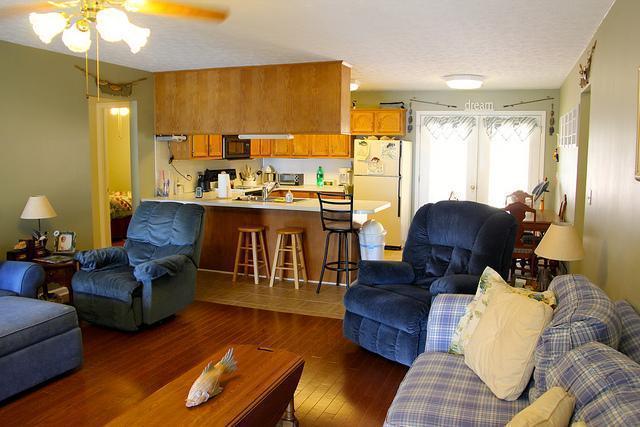What is on the brown table near the couch?
Indicate the correct response and explain using: 'Answer: answer
Rationale: rationale.'
Options: Cat, baby, fish, apple. Answer: fish.
Rationale: The table has fish. 